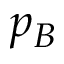Convert formula to latex. <formula><loc_0><loc_0><loc_500><loc_500>p _ { B }</formula> 